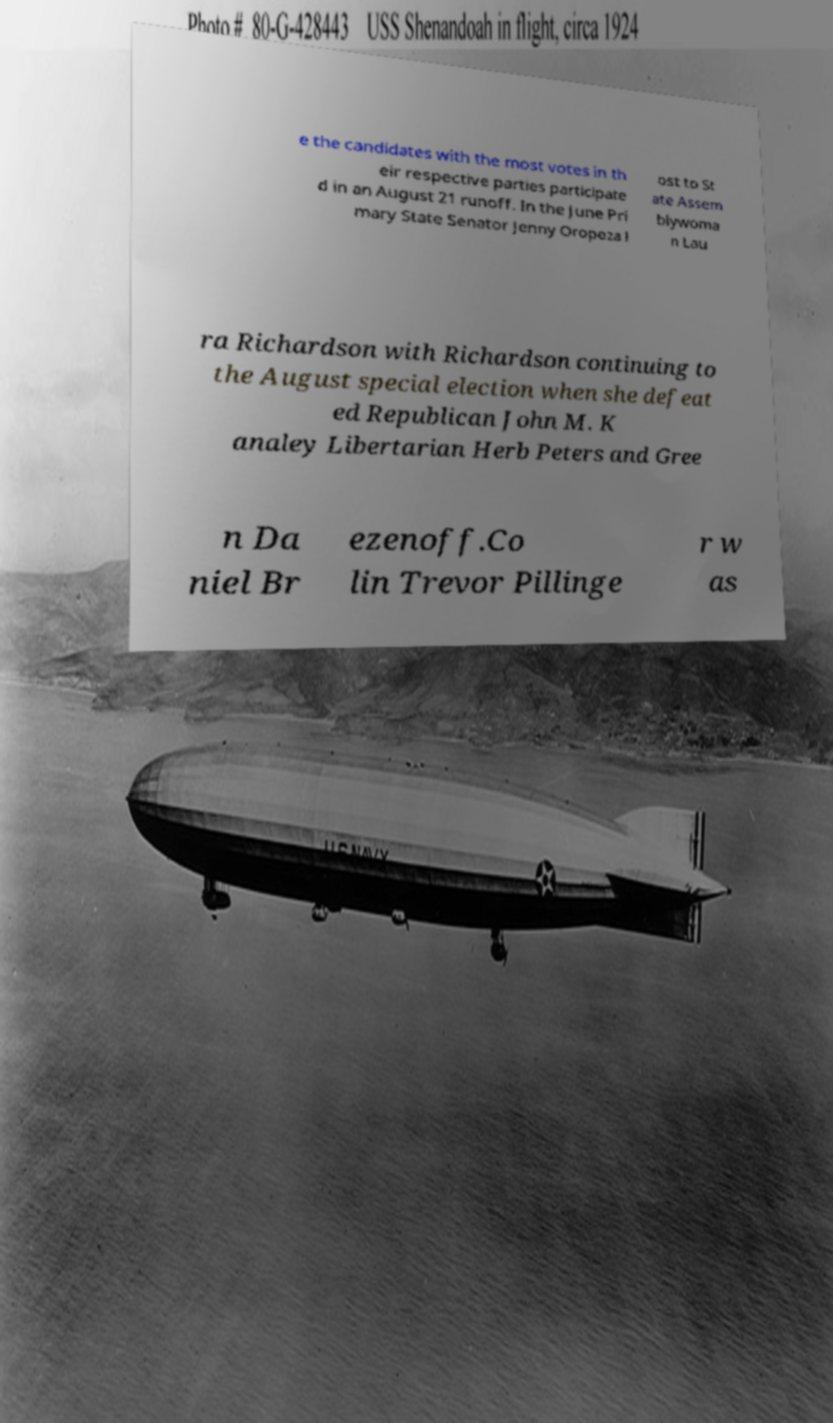There's text embedded in this image that I need extracted. Can you transcribe it verbatim? e the candidates with the most votes in th eir respective parties participate d in an August 21 runoff. In the June Pri mary State Senator Jenny Oropeza l ost to St ate Assem blywoma n Lau ra Richardson with Richardson continuing to the August special election when she defeat ed Republican John M. K analey Libertarian Herb Peters and Gree n Da niel Br ezenoff.Co lin Trevor Pillinge r w as 